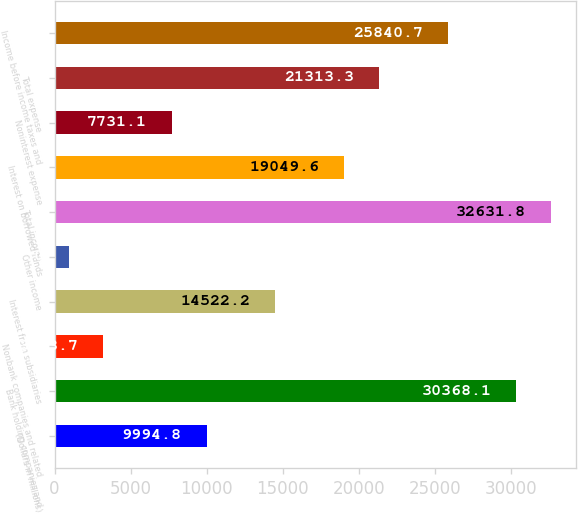Convert chart. <chart><loc_0><loc_0><loc_500><loc_500><bar_chart><fcel>(Dollars in millions)<fcel>Bank holding companies and<fcel>Nonbank companies and related<fcel>Interest from subsidiaries<fcel>Other income<fcel>Total income<fcel>Interest on borrowed funds<fcel>Noninterest expense<fcel>Total expense<fcel>Income before income taxes and<nl><fcel>9994.8<fcel>30368.1<fcel>3203.7<fcel>14522.2<fcel>940<fcel>32631.8<fcel>19049.6<fcel>7731.1<fcel>21313.3<fcel>25840.7<nl></chart> 